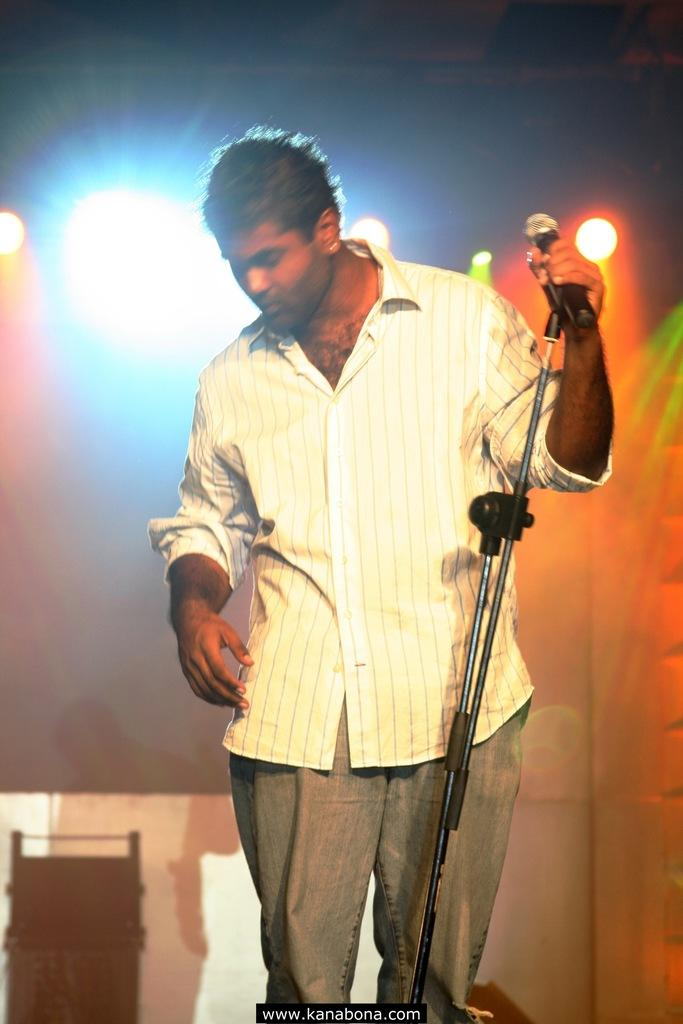Who is present in the image? There is a man in the image. What is the man holding in the image? The man is holding a microphone. What can be seen in the background of the image? There are several lights in the background of the image. How many bikes are parked next to the man in the image? There are no bikes present in the image. What emotion does the man express towards the audience in the image? The image does not convey any specific emotion or sentiment, so it cannot be determined how the man feels towards the audience. 